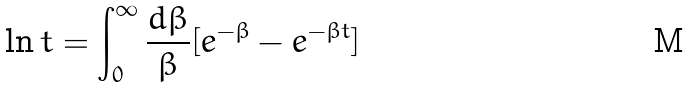Convert formula to latex. <formula><loc_0><loc_0><loc_500><loc_500>\ln t = \int _ { 0 } ^ { \infty } \frac { d \beta } { \beta } [ e ^ { - \beta } - e ^ { - \beta t } ]</formula> 